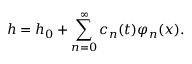Convert formula to latex. <formula><loc_0><loc_0><loc_500><loc_500>h = h _ { 0 } + \sum _ { n = 0 } ^ { \infty } c _ { n } ( t ) \varphi _ { n } ( x ) .</formula> 